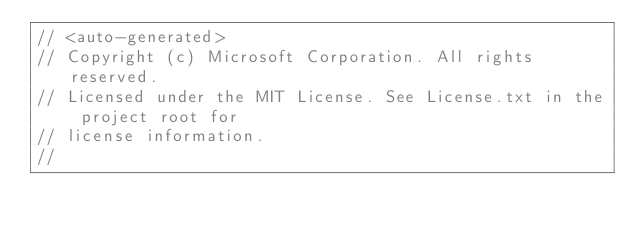<code> <loc_0><loc_0><loc_500><loc_500><_C#_>// <auto-generated>
// Copyright (c) Microsoft Corporation. All rights reserved.
// Licensed under the MIT License. See License.txt in the project root for
// license information.
//</code> 